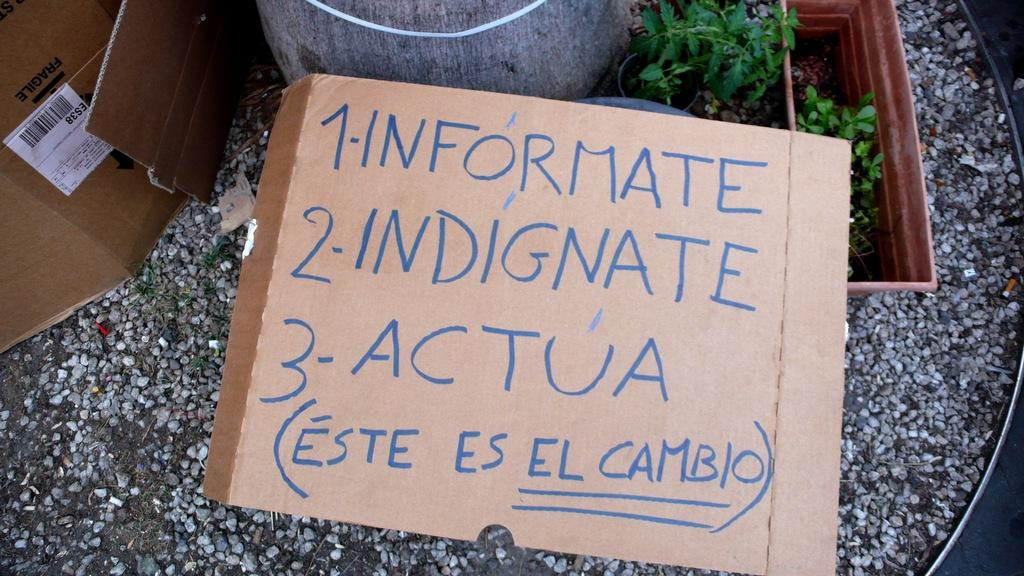What type of material is used for the objects in the image? There are cardboards in the image. What is written or printed on the cardboard? There is text on the cardboard. What type of vegetation can be seen in the image? There are plants in flower pots in the image. What type of natural elements are present in the image? There are stones in the image. Can you describe any other objects present in the image? There are other objects present in the image, but their specific details are not mentioned in the provided facts. What book is being read by the plant in the image? There is no book or plant reading a book present in the image. What type of growth is observed on the stones in the image? There is no growth or any living organisms on the stones in the image. 